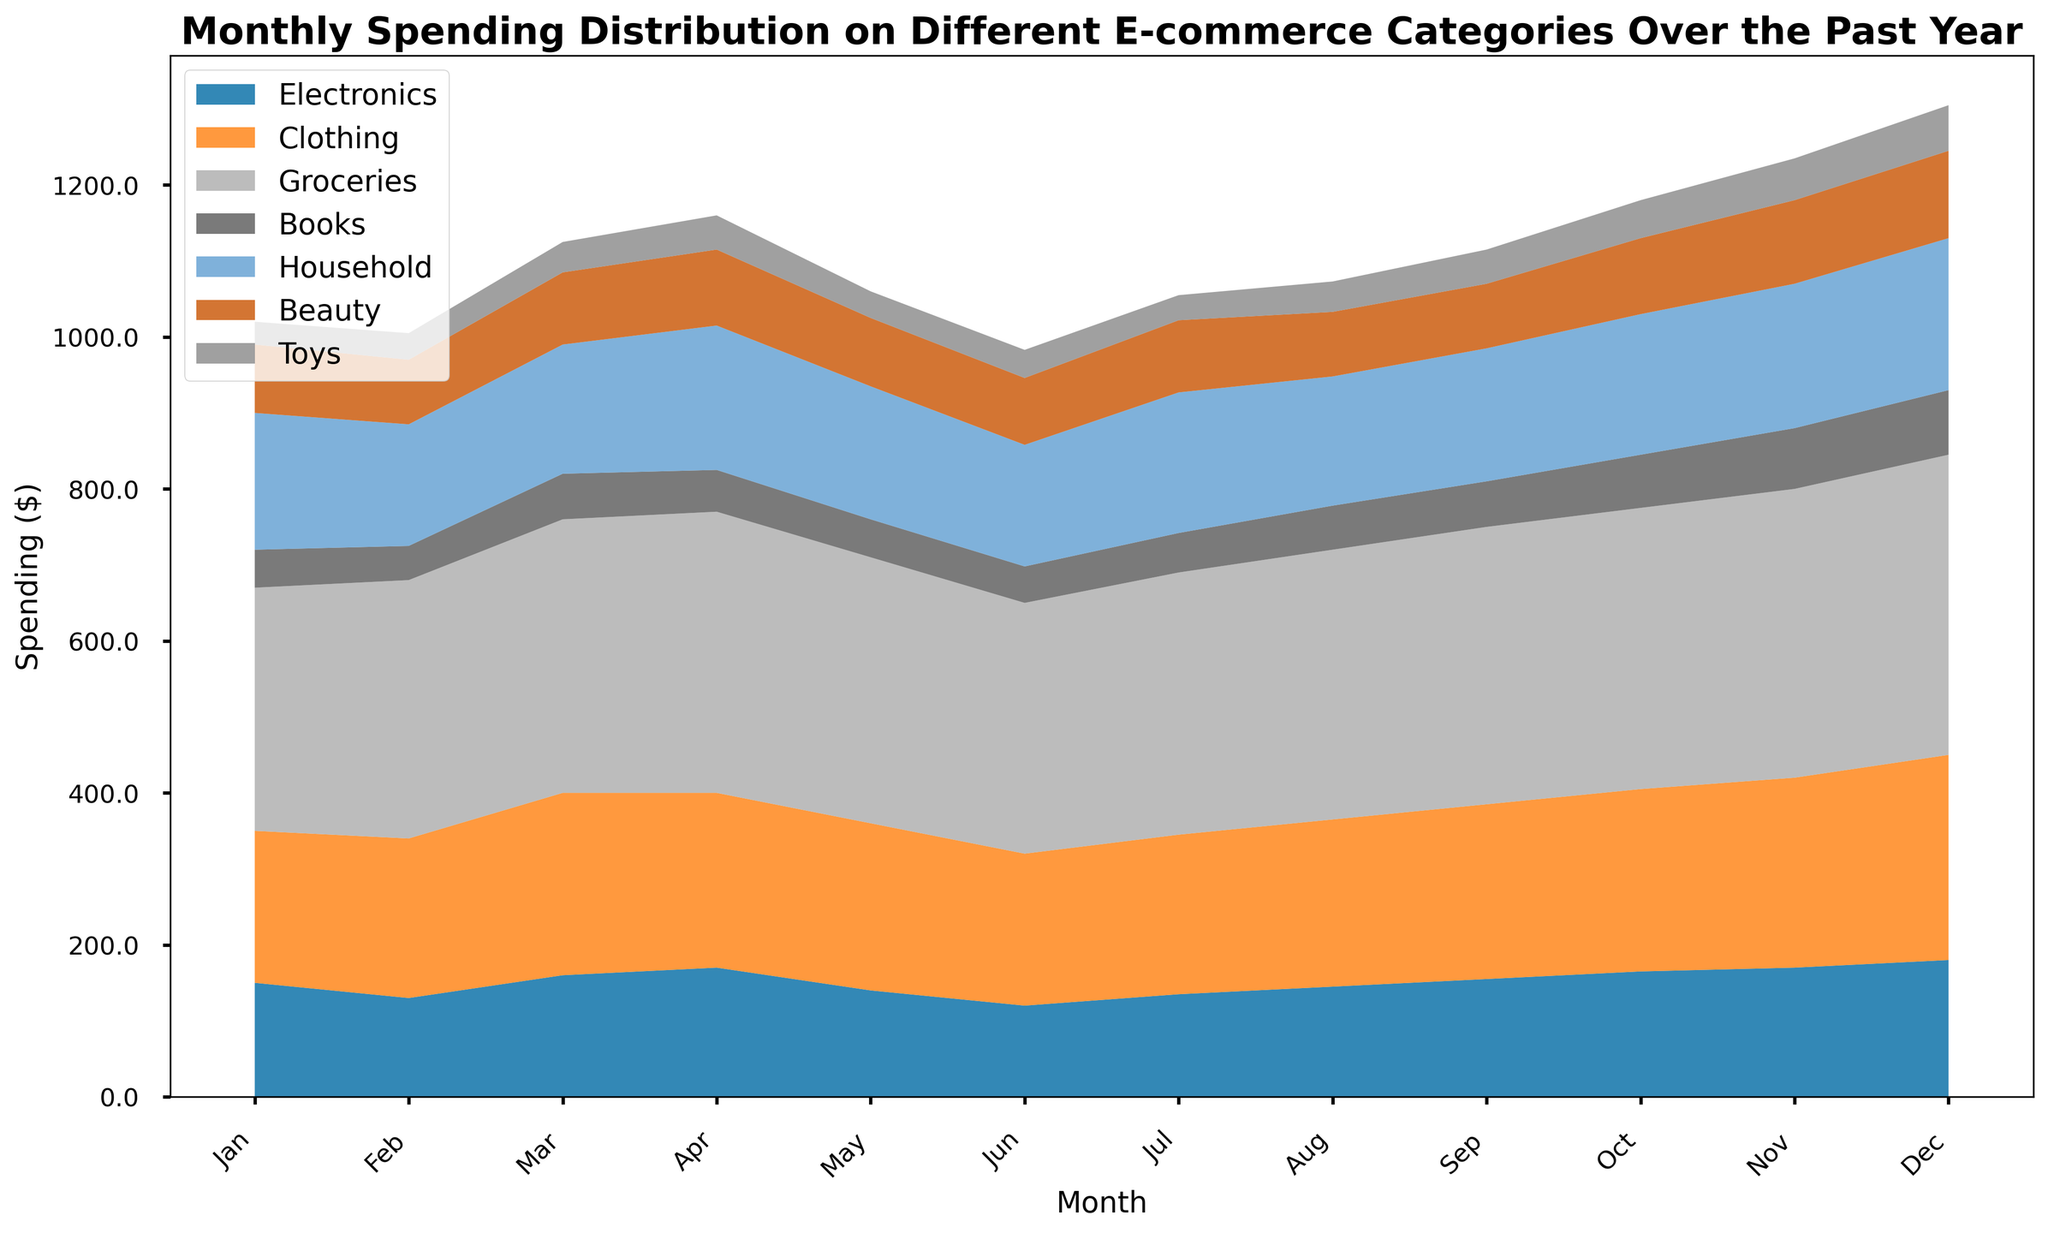What's the overall spending trend for Electronics over the year? Looking at the area representing Electronics in the chart, it starts from $150 in January and gradually increases to $180 in December. This indicates a rising trend.
Answer: Rising trend Which month saw the highest spending on Groceries? Observing the area corresponding to Groceries, December has the largest section, indicating the highest spending. The exact label value for December's Groceries is $395.
Answer: December Comparing February and March, which month had higher spending on Beauty products? In the area for Beauty, March's section is higher than February's. March's value is $95, whereas February's is $85.
Answer: March By how much did spending on Books increase from April to October? The spending on Books increases from $55 in April to $70 in October. The difference is $70 - $55 = $15.
Answer: $15 Which category had the least spending in January? Comparing the areas, Toys had the smallest section in January with a value of $30.
Answer: Toys In which month did Clothing spending peak? Observing the areas for Clothing, December has the tallest section, indicating the peak spending of $270.
Answer: December What is the total spending on Household items in April and May combined? The spending on Household in April is $190 and in May is $175. The total is $190 + $175 = $365.
Answer: $365 How does the spending on Toys in December compare to that in June? Comparing the areas for Toys, December's section is higher than June's. December's value is $60, while June's is $37.
Answer: December is higher What's the average monthly spending on Beauty products? To find the average, sum the monthly values from January to December for Beauty and divide by 12.  Total: 90+85+95+100+90+88+95+85+85+100+110+115 = 1138. Average: 1138 / 12 ≈ 94.83.
Answer: ≈ $94.83 Which category's spending remains relatively stable throughout the year? Observing the areas, Clothing shows the most stable trend with less fluctuation and a consistent increase.
Answer: Clothing 